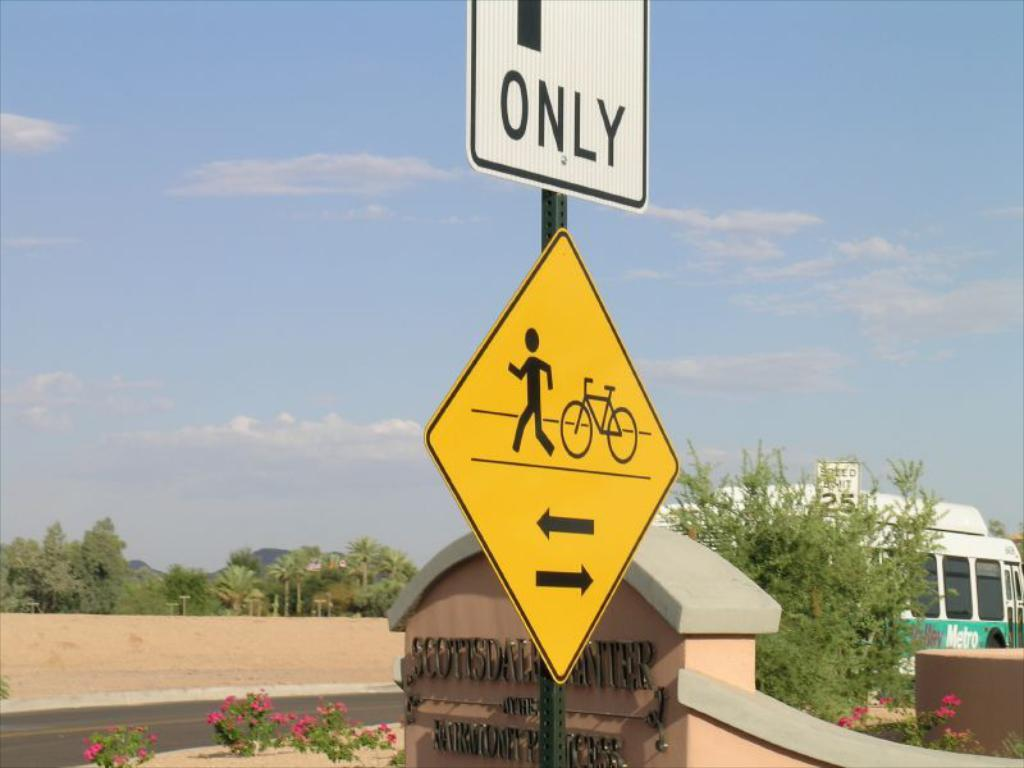Provide a one-sentence caption for the provided image. A white sign on which the word ONLY is visible, above a yellow and black sign with a picture of a man and a bike. 